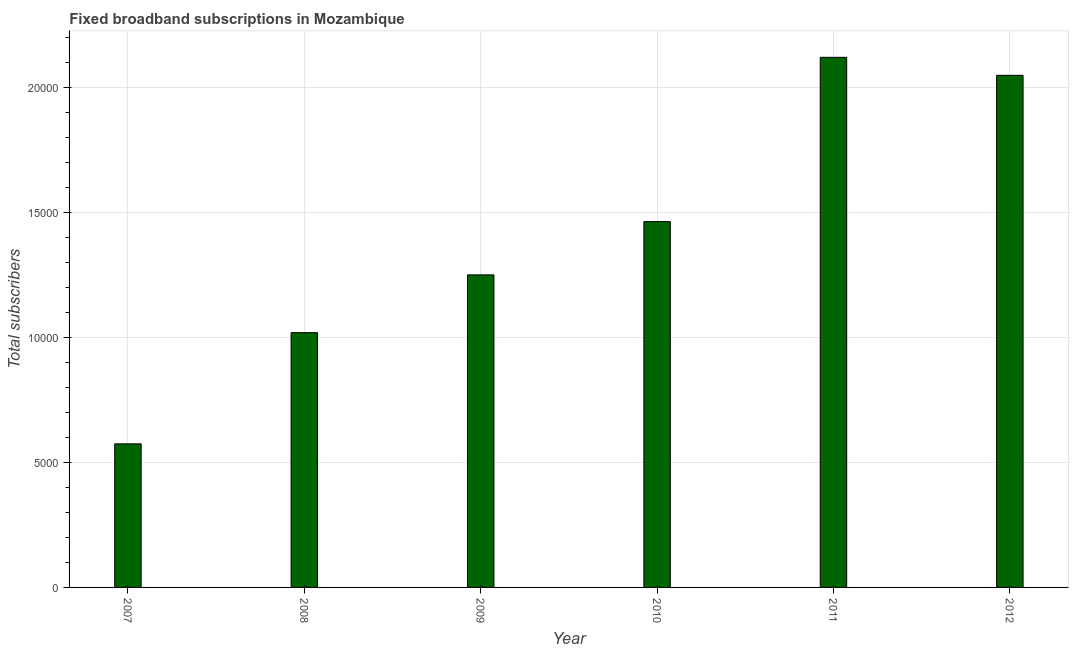Does the graph contain any zero values?
Offer a very short reply. No. Does the graph contain grids?
Your answer should be compact. Yes. What is the title of the graph?
Offer a very short reply. Fixed broadband subscriptions in Mozambique. What is the label or title of the X-axis?
Your response must be concise. Year. What is the label or title of the Y-axis?
Your answer should be very brief. Total subscribers. What is the total number of fixed broadband subscriptions in 2009?
Ensure brevity in your answer.  1.25e+04. Across all years, what is the maximum total number of fixed broadband subscriptions?
Give a very brief answer. 2.12e+04. Across all years, what is the minimum total number of fixed broadband subscriptions?
Offer a terse response. 5743. What is the sum of the total number of fixed broadband subscriptions?
Your response must be concise. 8.48e+04. What is the difference between the total number of fixed broadband subscriptions in 2009 and 2010?
Make the answer very short. -2131. What is the average total number of fixed broadband subscriptions per year?
Offer a very short reply. 1.41e+04. What is the median total number of fixed broadband subscriptions?
Ensure brevity in your answer.  1.36e+04. In how many years, is the total number of fixed broadband subscriptions greater than 19000 ?
Keep it short and to the point. 2. Do a majority of the years between 2010 and 2012 (inclusive) have total number of fixed broadband subscriptions greater than 15000 ?
Offer a terse response. Yes. What is the ratio of the total number of fixed broadband subscriptions in 2008 to that in 2012?
Your answer should be very brief. 0.5. Is the total number of fixed broadband subscriptions in 2009 less than that in 2010?
Offer a very short reply. Yes. Is the difference between the total number of fixed broadband subscriptions in 2008 and 2011 greater than the difference between any two years?
Your response must be concise. No. What is the difference between the highest and the second highest total number of fixed broadband subscriptions?
Offer a very short reply. 720. What is the difference between the highest and the lowest total number of fixed broadband subscriptions?
Your answer should be compact. 1.55e+04. Are all the bars in the graph horizontal?
Keep it short and to the point. No. What is the difference between two consecutive major ticks on the Y-axis?
Your answer should be compact. 5000. Are the values on the major ticks of Y-axis written in scientific E-notation?
Give a very brief answer. No. What is the Total subscribers in 2007?
Offer a terse response. 5743. What is the Total subscribers of 2008?
Give a very brief answer. 1.02e+04. What is the Total subscribers of 2009?
Provide a short and direct response. 1.25e+04. What is the Total subscribers of 2010?
Your response must be concise. 1.46e+04. What is the Total subscribers in 2011?
Provide a short and direct response. 2.12e+04. What is the Total subscribers of 2012?
Provide a succinct answer. 2.05e+04. What is the difference between the Total subscribers in 2007 and 2008?
Your response must be concise. -4448. What is the difference between the Total subscribers in 2007 and 2009?
Your response must be concise. -6759. What is the difference between the Total subscribers in 2007 and 2010?
Give a very brief answer. -8890. What is the difference between the Total subscribers in 2007 and 2011?
Offer a very short reply. -1.55e+04. What is the difference between the Total subscribers in 2007 and 2012?
Ensure brevity in your answer.  -1.47e+04. What is the difference between the Total subscribers in 2008 and 2009?
Provide a succinct answer. -2311. What is the difference between the Total subscribers in 2008 and 2010?
Offer a very short reply. -4442. What is the difference between the Total subscribers in 2008 and 2011?
Offer a terse response. -1.10e+04. What is the difference between the Total subscribers in 2008 and 2012?
Your answer should be very brief. -1.03e+04. What is the difference between the Total subscribers in 2009 and 2010?
Provide a succinct answer. -2131. What is the difference between the Total subscribers in 2009 and 2011?
Your answer should be very brief. -8702. What is the difference between the Total subscribers in 2009 and 2012?
Offer a very short reply. -7982. What is the difference between the Total subscribers in 2010 and 2011?
Offer a very short reply. -6571. What is the difference between the Total subscribers in 2010 and 2012?
Offer a very short reply. -5851. What is the difference between the Total subscribers in 2011 and 2012?
Give a very brief answer. 720. What is the ratio of the Total subscribers in 2007 to that in 2008?
Your response must be concise. 0.56. What is the ratio of the Total subscribers in 2007 to that in 2009?
Give a very brief answer. 0.46. What is the ratio of the Total subscribers in 2007 to that in 2010?
Offer a terse response. 0.39. What is the ratio of the Total subscribers in 2007 to that in 2011?
Ensure brevity in your answer.  0.27. What is the ratio of the Total subscribers in 2007 to that in 2012?
Your answer should be compact. 0.28. What is the ratio of the Total subscribers in 2008 to that in 2009?
Offer a terse response. 0.81. What is the ratio of the Total subscribers in 2008 to that in 2010?
Provide a succinct answer. 0.7. What is the ratio of the Total subscribers in 2008 to that in 2011?
Your response must be concise. 0.48. What is the ratio of the Total subscribers in 2008 to that in 2012?
Offer a terse response. 0.5. What is the ratio of the Total subscribers in 2009 to that in 2010?
Ensure brevity in your answer.  0.85. What is the ratio of the Total subscribers in 2009 to that in 2011?
Keep it short and to the point. 0.59. What is the ratio of the Total subscribers in 2009 to that in 2012?
Make the answer very short. 0.61. What is the ratio of the Total subscribers in 2010 to that in 2011?
Your answer should be compact. 0.69. What is the ratio of the Total subscribers in 2010 to that in 2012?
Offer a very short reply. 0.71. What is the ratio of the Total subscribers in 2011 to that in 2012?
Give a very brief answer. 1.03. 